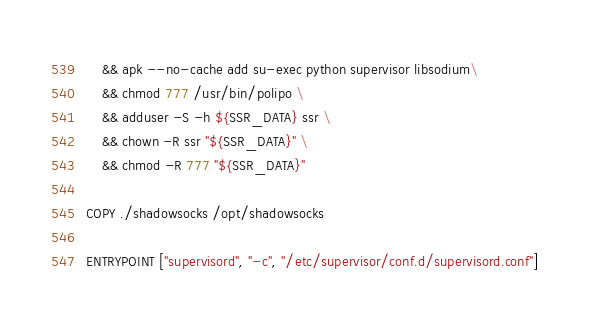<code> <loc_0><loc_0><loc_500><loc_500><_Dockerfile_>    && apk --no-cache add su-exec python supervisor libsodium\
    && chmod 777 /usr/bin/polipo \
    && adduser -S -h ${SSR_DATA} ssr \
    && chown -R ssr "${SSR_DATA}" \
    && chmod -R 777 "${SSR_DATA}"

COPY ./shadowsocks /opt/shadowsocks

ENTRYPOINT ["supervisord", "-c", "/etc/supervisor/conf.d/supervisord.conf"]
</code> 